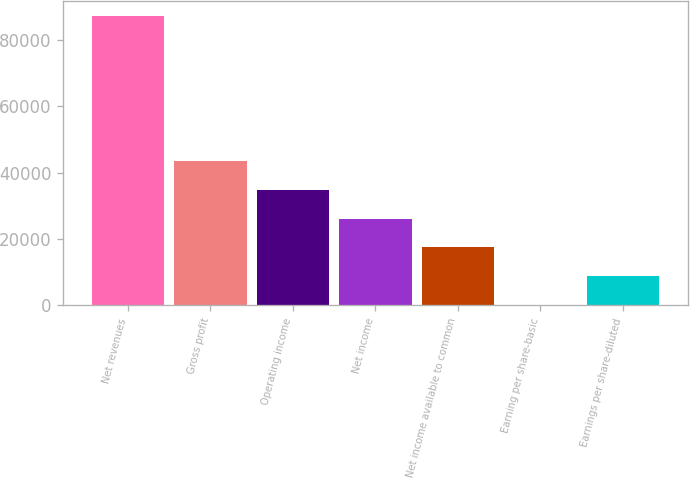Convert chart. <chart><loc_0><loc_0><loc_500><loc_500><bar_chart><fcel>Net revenues<fcel>Gross profit<fcel>Operating income<fcel>Net income<fcel>Net income available to common<fcel>Earning per share-basic<fcel>Earnings per share-diluted<nl><fcel>87303<fcel>43651.5<fcel>34921.2<fcel>26191<fcel>17460.7<fcel>0.08<fcel>8730.37<nl></chart> 